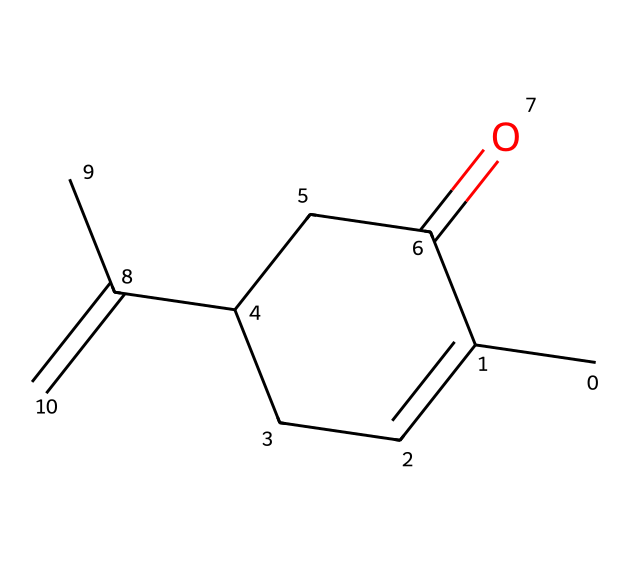What is the molecular formula of carvone? To find the molecular formula, count the number of carbon (C), hydrogen (H), and oxygen (O) atoms in the SMILES representation. There are 10 carbon atoms, 14 hydrogen atoms, and 1 oxygen atom. Therefore, the molecular formula is C10H14O.
Answer: C10H14O How many chiral centers are present in carvone? A chiral center is usually defined as a carbon atom bonded to four different groups. Analyzing the structure, there is one carbon atom that has four distinct substituents. Thus, there is one chiral center in carvone.
Answer: 1 What is the functional group present in carvone? The structure has a carbonyl group (C=O) visible from the ketone functionality in the ring. This indicates that carvone contains a ketone as its functional group.
Answer: ketone Which isomer of carvone has a minty smell? Carvone has two enantiomers: (R)-carvone (natural source, minty smell) and (S)-carvone (caraway-like smell). The (R)-enantiomer is associated with the minty scent.
Answer: (R)-carvone Is carvone a saturated or unsaturated compound? By observing the structure, it contains double bonds (C=C), indicating the presence of unsaturation. Thus, carvone is classified as an unsaturated compound.
Answer: unsaturated What type of symmetry does carvone exhibit? Chiral compounds by definition lack symmetry with respect to a plane of symmetry, and given there is only one chiral center and no internal symmetry elements, carvone exhibits no symmetry.
Answer: no symmetry 